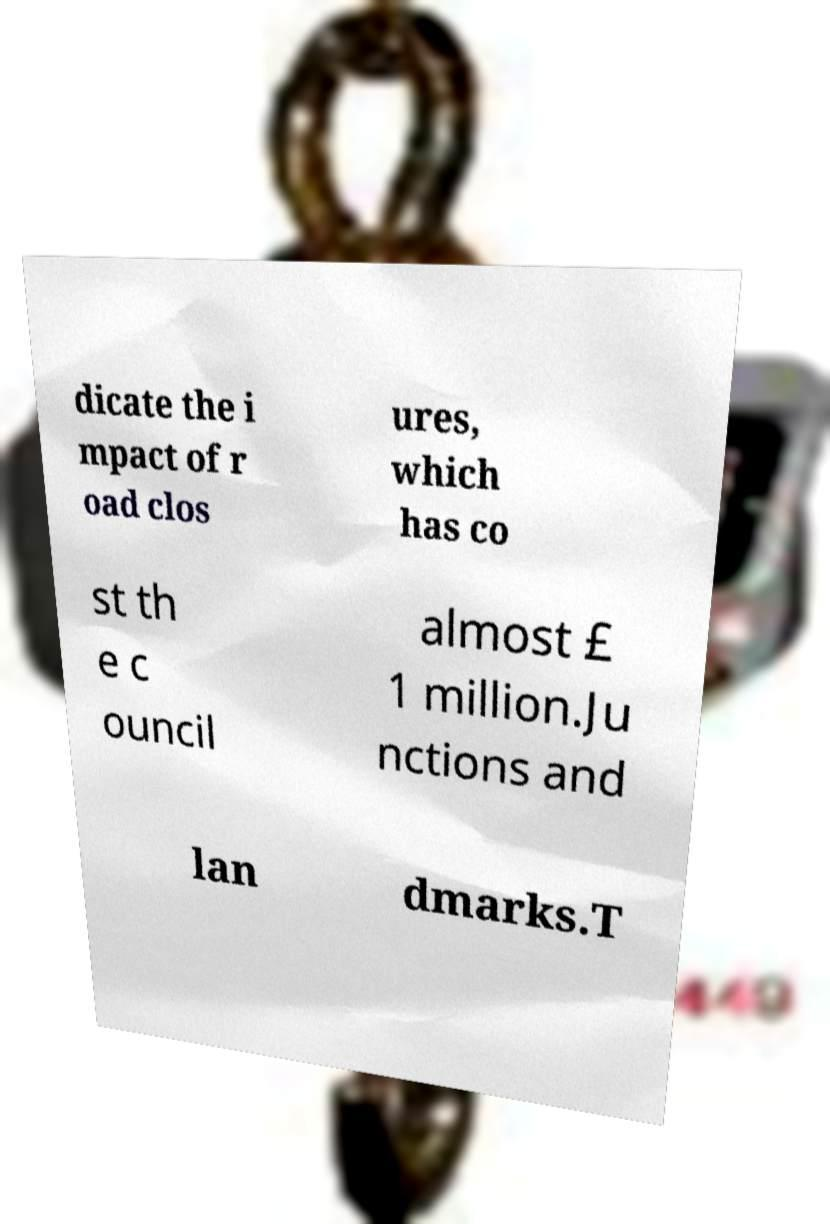I need the written content from this picture converted into text. Can you do that? dicate the i mpact of r oad clos ures, which has co st th e c ouncil almost £ 1 million.Ju nctions and lan dmarks.T 